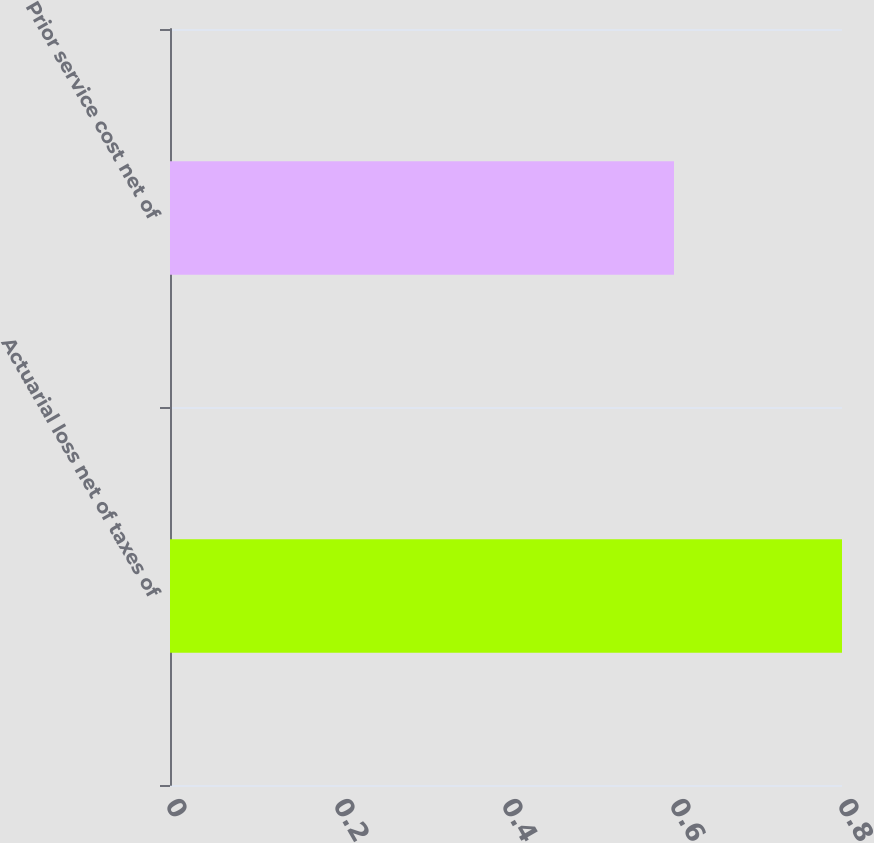<chart> <loc_0><loc_0><loc_500><loc_500><bar_chart><fcel>Actuarial loss net of taxes of<fcel>Prior service cost net of<nl><fcel>0.8<fcel>0.6<nl></chart> 